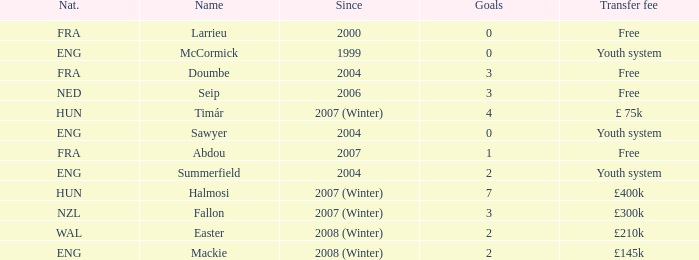What is the starting year for the player with over 3 goals and a transfer fee of £400k? 2007 (Winter). 